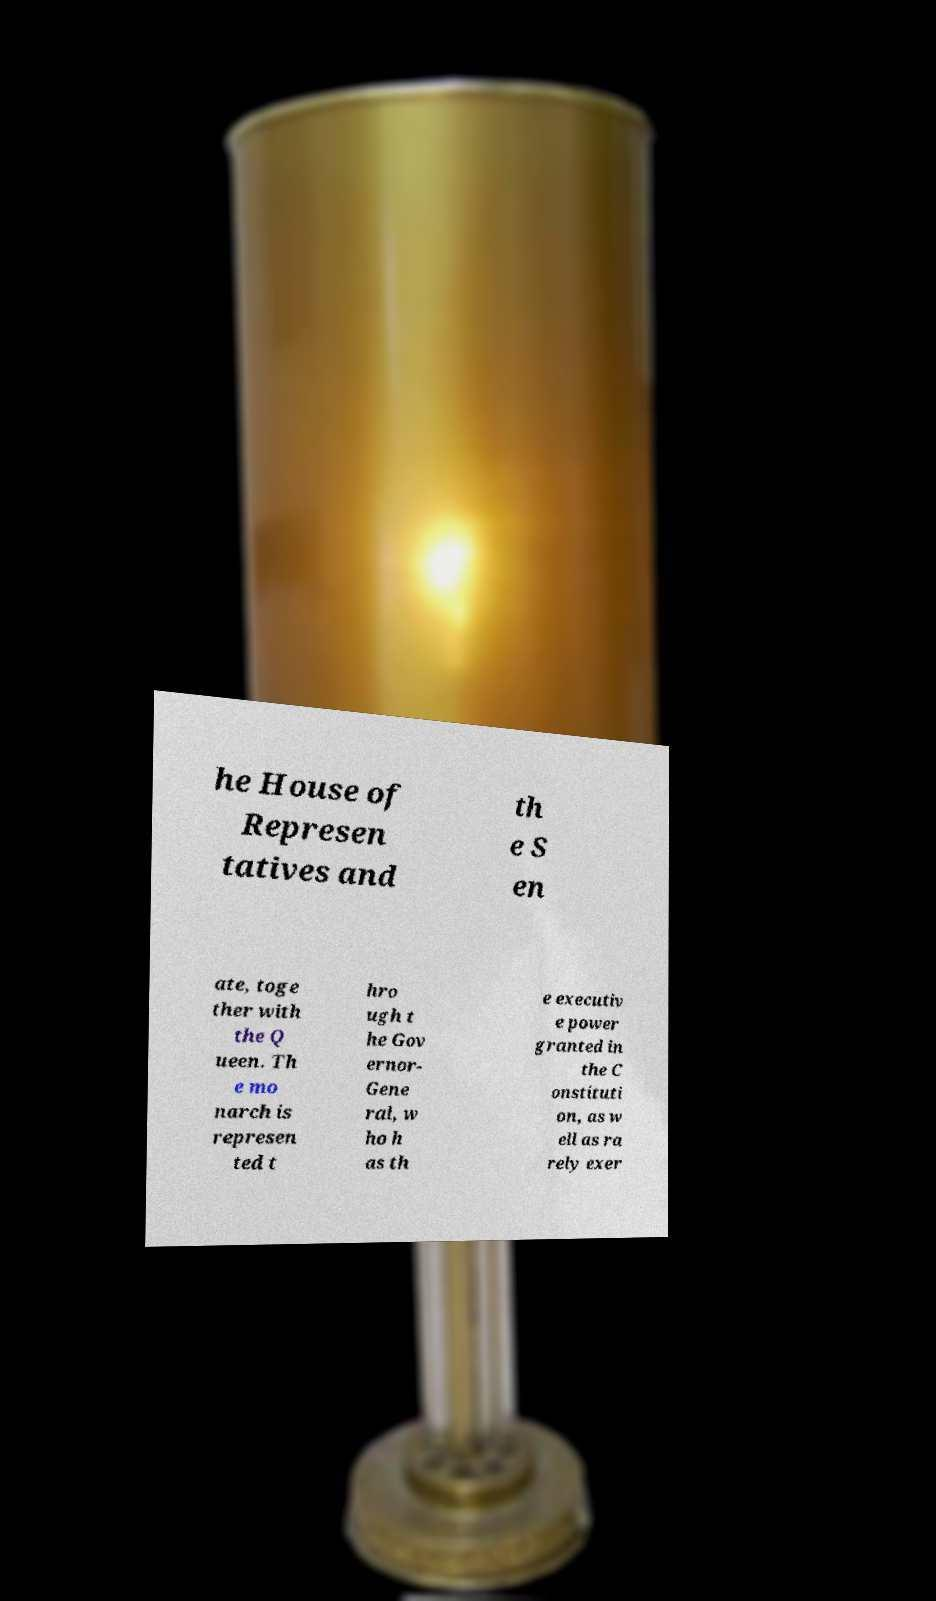Could you extract and type out the text from this image? he House of Represen tatives and th e S en ate, toge ther with the Q ueen. Th e mo narch is represen ted t hro ugh t he Gov ernor- Gene ral, w ho h as th e executiv e power granted in the C onstituti on, as w ell as ra rely exer 